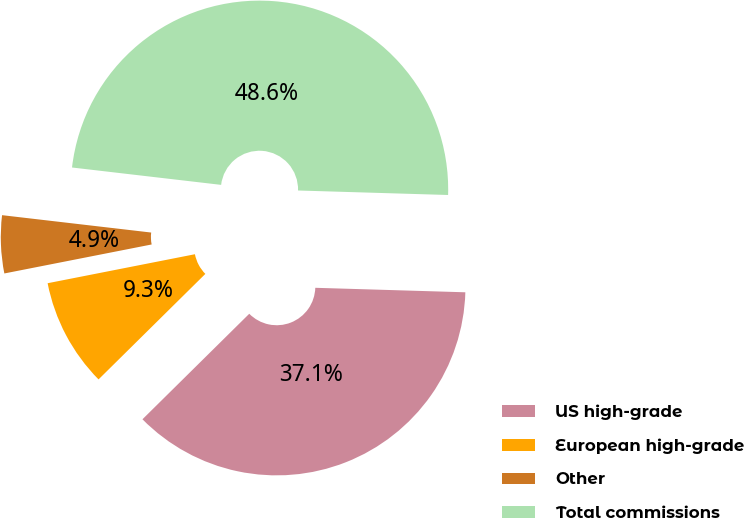Convert chart. <chart><loc_0><loc_0><loc_500><loc_500><pie_chart><fcel>US high-grade<fcel>European high-grade<fcel>Other<fcel>Total commissions<nl><fcel>37.12%<fcel>9.31%<fcel>4.94%<fcel>48.63%<nl></chart> 